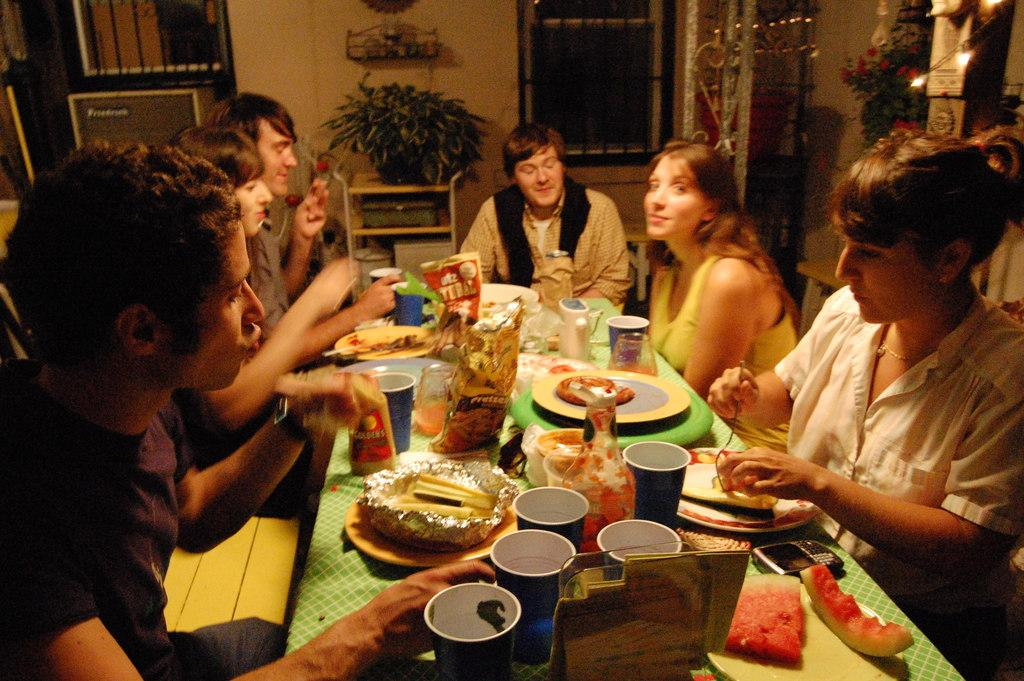What are the people in the image doing? The people in the image are sitting around the table. What can be seen in the background of the image? There is a tree and a window in the background of the image. What is on the table in the image? There is a glass, fruits, chips, and drinks on the table. What type of chain can be seen hanging from the light in the image? There is no chain or light present in the image. How does the image show respect for the environment? The image does not show any specific actions or elements that demonstrate respect for the environment. 